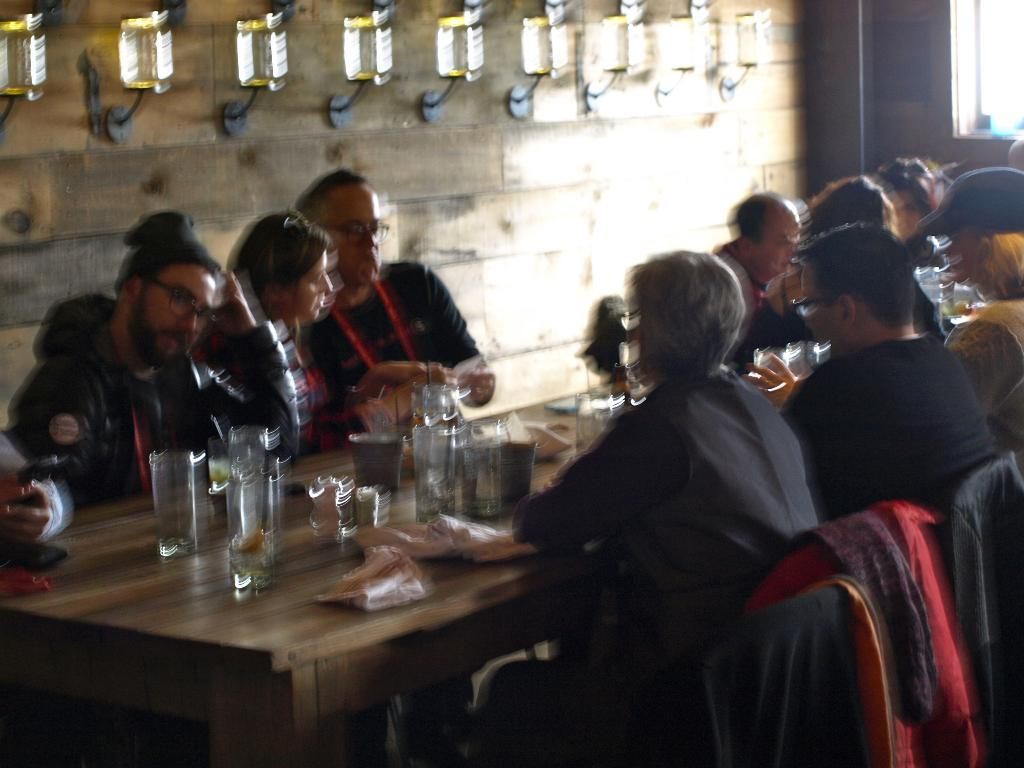What are the people in the image doing? The people in the image are sitting on chairs at a table. What objects can be seen on the table? There are glasses, tissue papers, and plates on the table. What can be seen in the background of the image? There is a wall, a window, and lights in the background. What type of whip is being used by the people in the image? There is no whip present in the image; the people are sitting at a table with glasses, tissue papers, and plates. What metal object is being regretted by the people in the image? There is no mention of regret or any metal object in the image. 